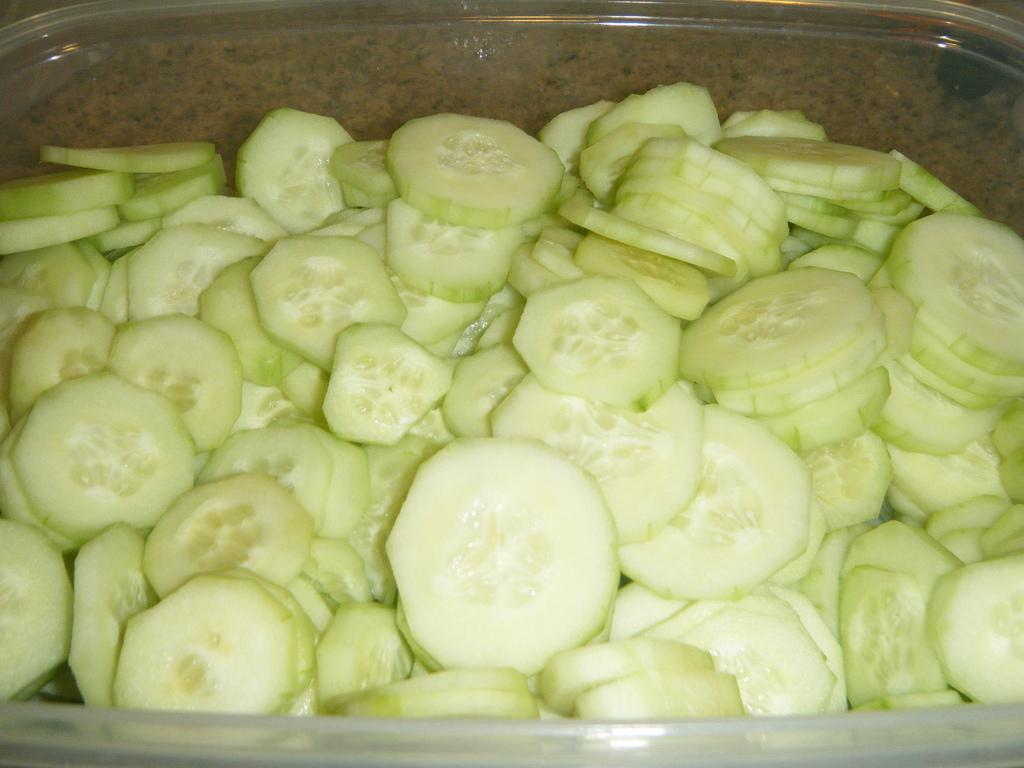What type of food can be seen in the image? There are cucumber pieces in the image. How are the cucumber pieces stored or contained? The cucumber pieces are in a container. What type of wool is being used to balance the snails in the image? There are no snails or wool present in the image; it only features cucumber pieces in a container. 